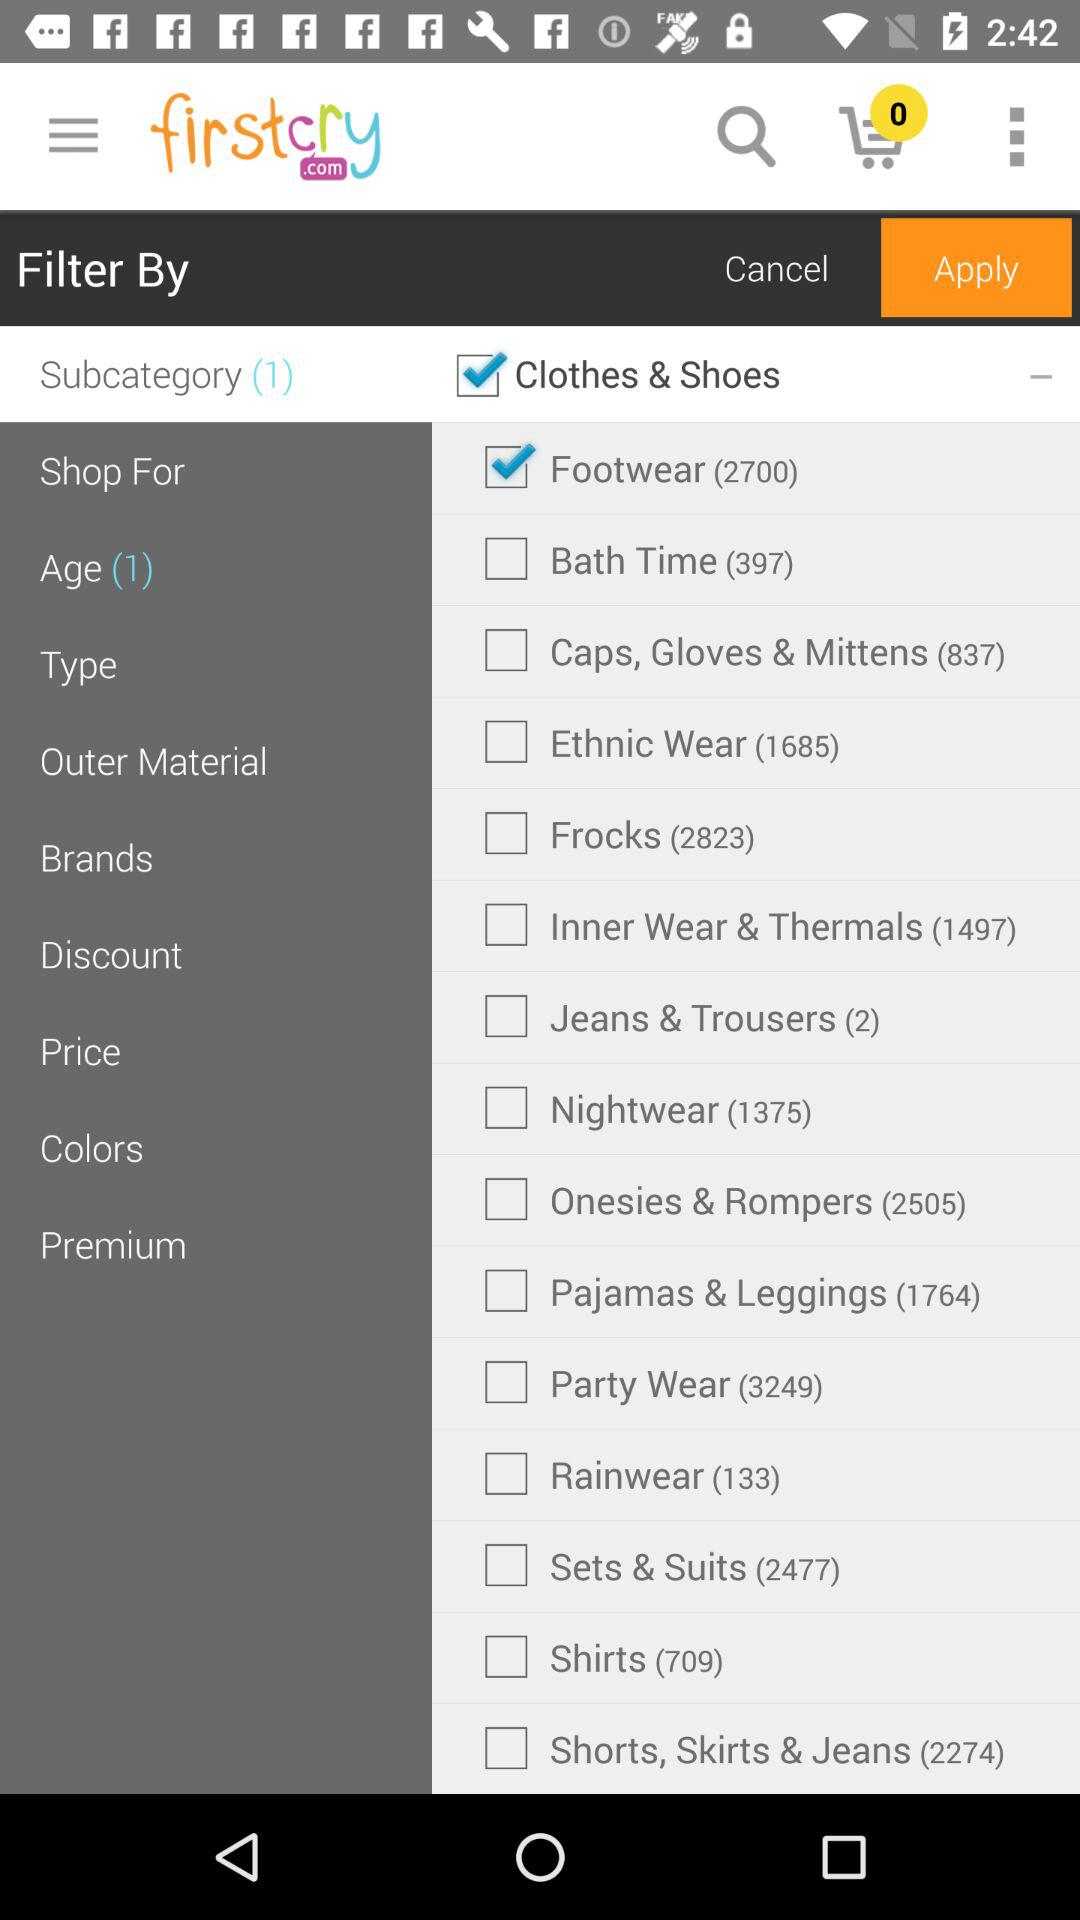How many items are added to the cart? There are 0 items. 